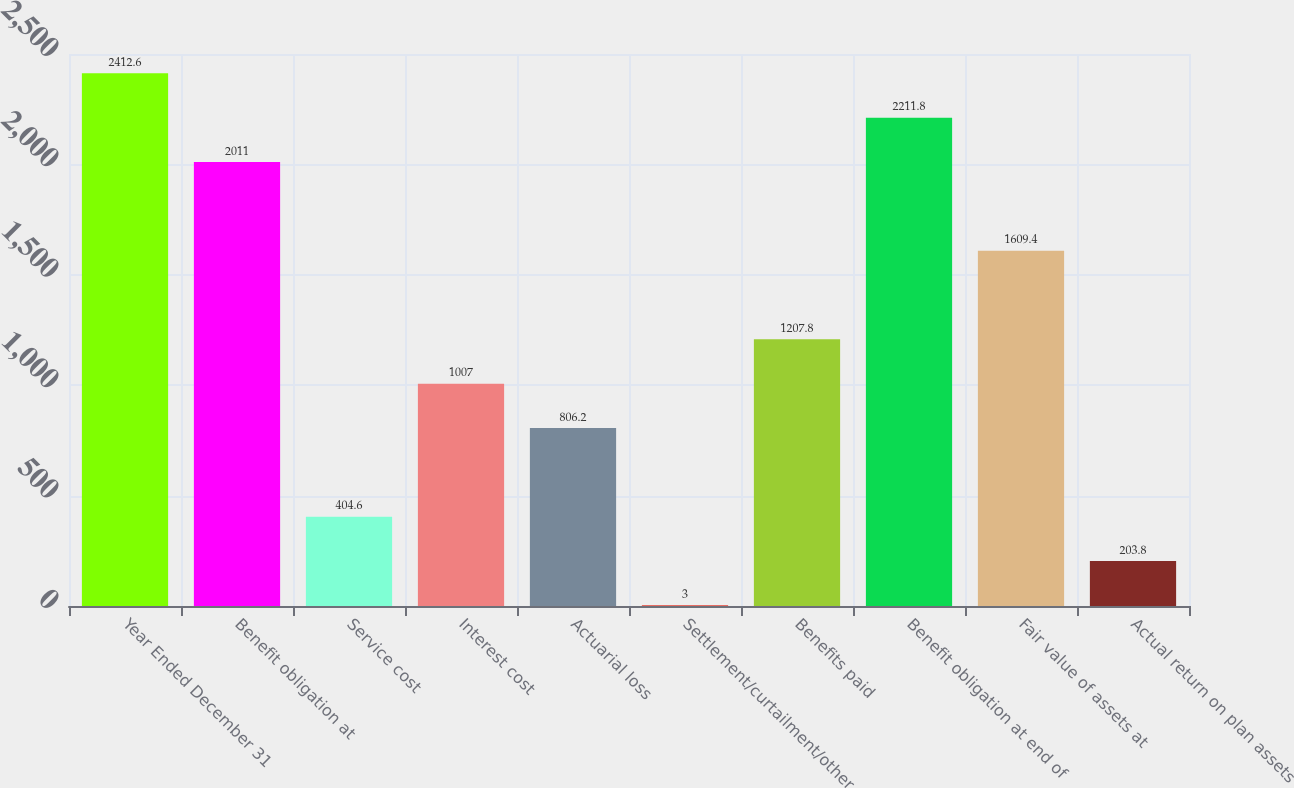Convert chart to OTSL. <chart><loc_0><loc_0><loc_500><loc_500><bar_chart><fcel>Year Ended December 31<fcel>Benefit obligation at<fcel>Service cost<fcel>Interest cost<fcel>Actuarial loss<fcel>Settlement/curtailment/other<fcel>Benefits paid<fcel>Benefit obligation at end of<fcel>Fair value of assets at<fcel>Actual return on plan assets<nl><fcel>2412.6<fcel>2011<fcel>404.6<fcel>1007<fcel>806.2<fcel>3<fcel>1207.8<fcel>2211.8<fcel>1609.4<fcel>203.8<nl></chart> 